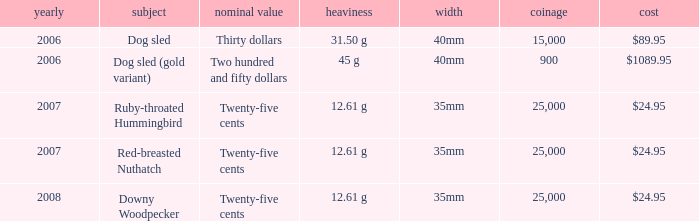What is the Mintage of the 12.61 g Weight Ruby-Throated Hummingbird? 1.0. 